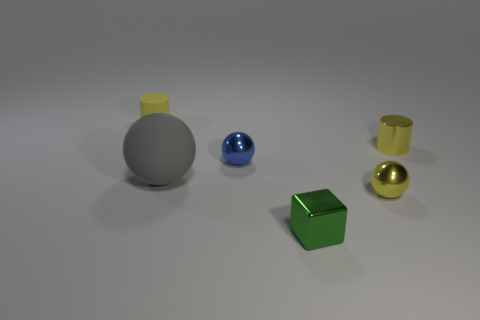There is a cylinder that is on the right side of the matte object right of the small yellow object that is behind the metal cylinder; what is its material?
Your response must be concise. Metal. What number of shiny things are either big blue cubes or gray objects?
Provide a short and direct response. 0. How many brown things are either metallic cylinders or tiny matte spheres?
Ensure brevity in your answer.  0. Is the color of the tiny ball to the right of the green metallic cube the same as the small matte cylinder?
Offer a very short reply. Yes. Is the material of the small green object the same as the blue ball?
Your response must be concise. Yes. Is the number of metal spheres that are to the left of the small green metallic thing the same as the number of matte objects behind the tiny yellow metallic ball?
Provide a short and direct response. No. There is a tiny blue object that is the same shape as the gray thing; what is it made of?
Provide a short and direct response. Metal. There is a rubber thing in front of the tiny yellow object behind the cylinder that is right of the matte cylinder; what is its shape?
Ensure brevity in your answer.  Sphere. Are there more shiny things in front of the large gray matte object than small green cubes?
Ensure brevity in your answer.  Yes. Do the large matte object to the left of the tiny green thing and the small blue shiny object have the same shape?
Your response must be concise. Yes. 